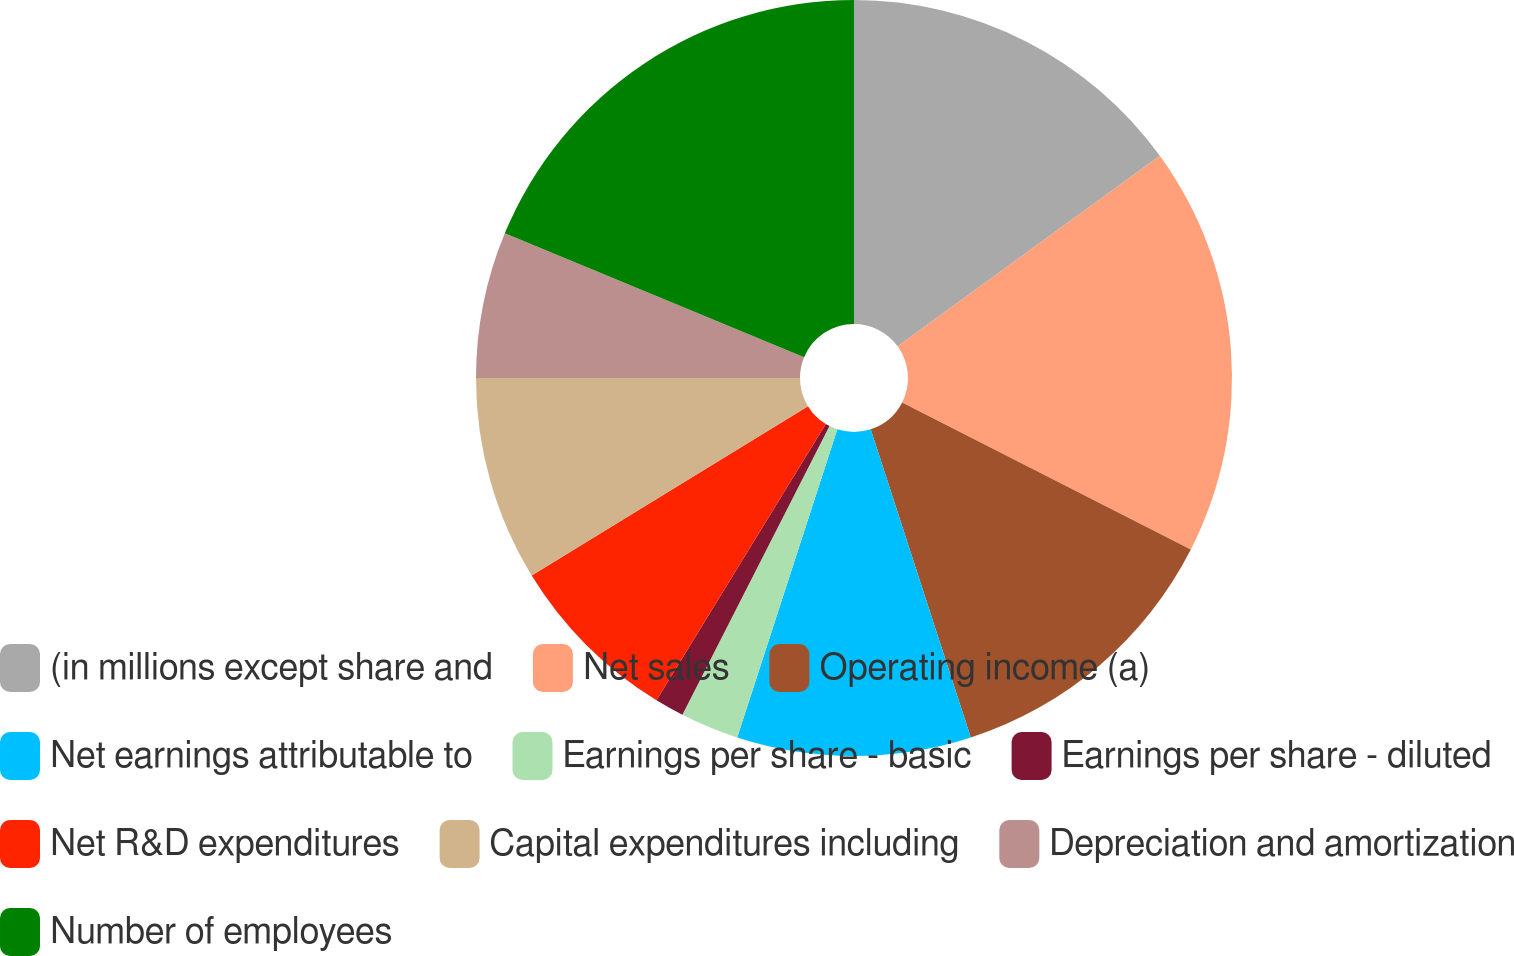<chart> <loc_0><loc_0><loc_500><loc_500><pie_chart><fcel>(in millions except share and<fcel>Net sales<fcel>Operating income (a)<fcel>Net earnings attributable to<fcel>Earnings per share - basic<fcel>Earnings per share - diluted<fcel>Net R&D expenditures<fcel>Capital expenditures including<fcel>Depreciation and amortization<fcel>Number of employees<nl><fcel>15.0%<fcel>17.5%<fcel>12.5%<fcel>10.0%<fcel>2.5%<fcel>1.25%<fcel>7.5%<fcel>8.75%<fcel>6.25%<fcel>18.75%<nl></chart> 